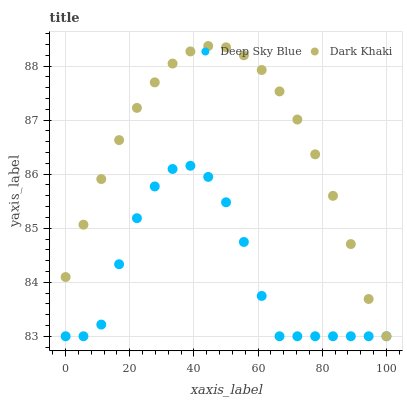Does Deep Sky Blue have the minimum area under the curve?
Answer yes or no. Yes. Does Dark Khaki have the maximum area under the curve?
Answer yes or no. Yes. Does Deep Sky Blue have the maximum area under the curve?
Answer yes or no. No. Is Dark Khaki the smoothest?
Answer yes or no. Yes. Is Deep Sky Blue the roughest?
Answer yes or no. Yes. Is Deep Sky Blue the smoothest?
Answer yes or no. No. Does Dark Khaki have the lowest value?
Answer yes or no. Yes. Does Dark Khaki have the highest value?
Answer yes or no. Yes. Does Deep Sky Blue have the highest value?
Answer yes or no. No. Does Deep Sky Blue intersect Dark Khaki?
Answer yes or no. Yes. Is Deep Sky Blue less than Dark Khaki?
Answer yes or no. No. Is Deep Sky Blue greater than Dark Khaki?
Answer yes or no. No. 